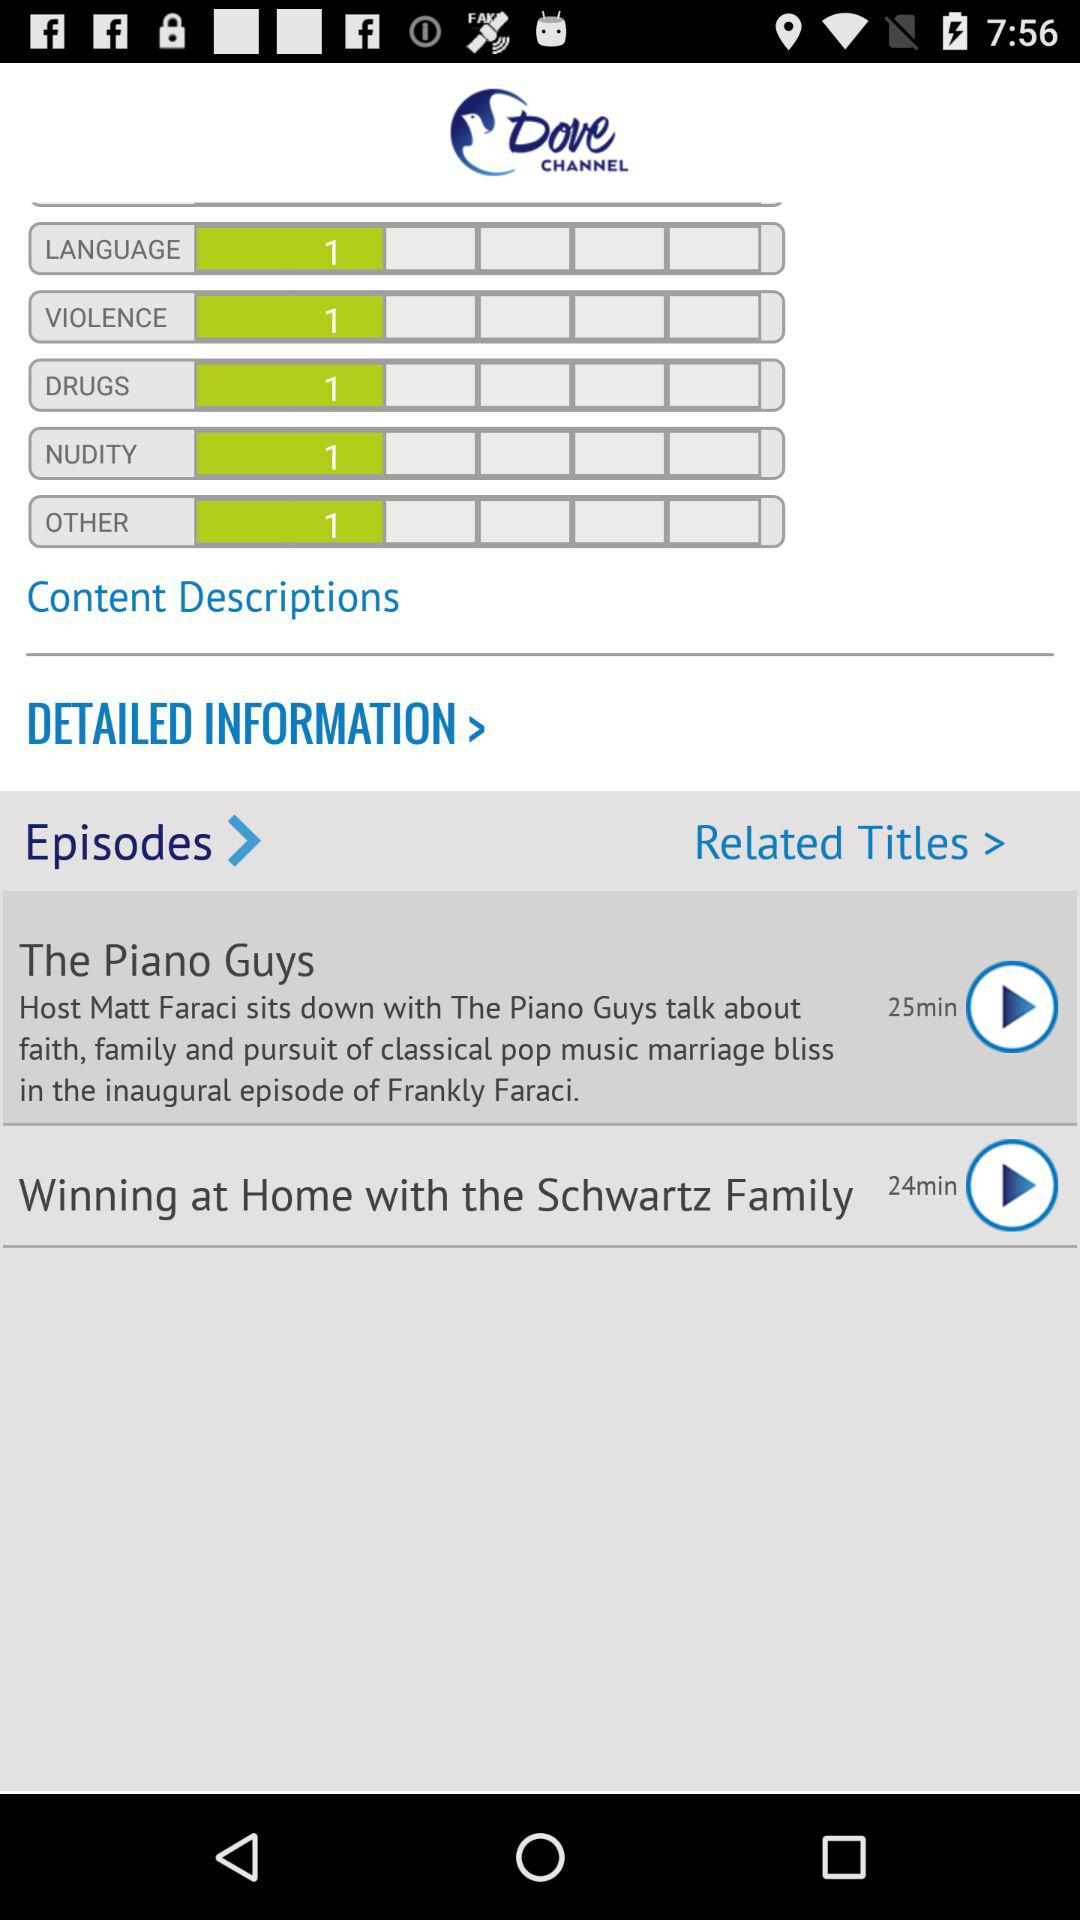How many episodes are there in total?
Answer the question using a single word or phrase. 2 